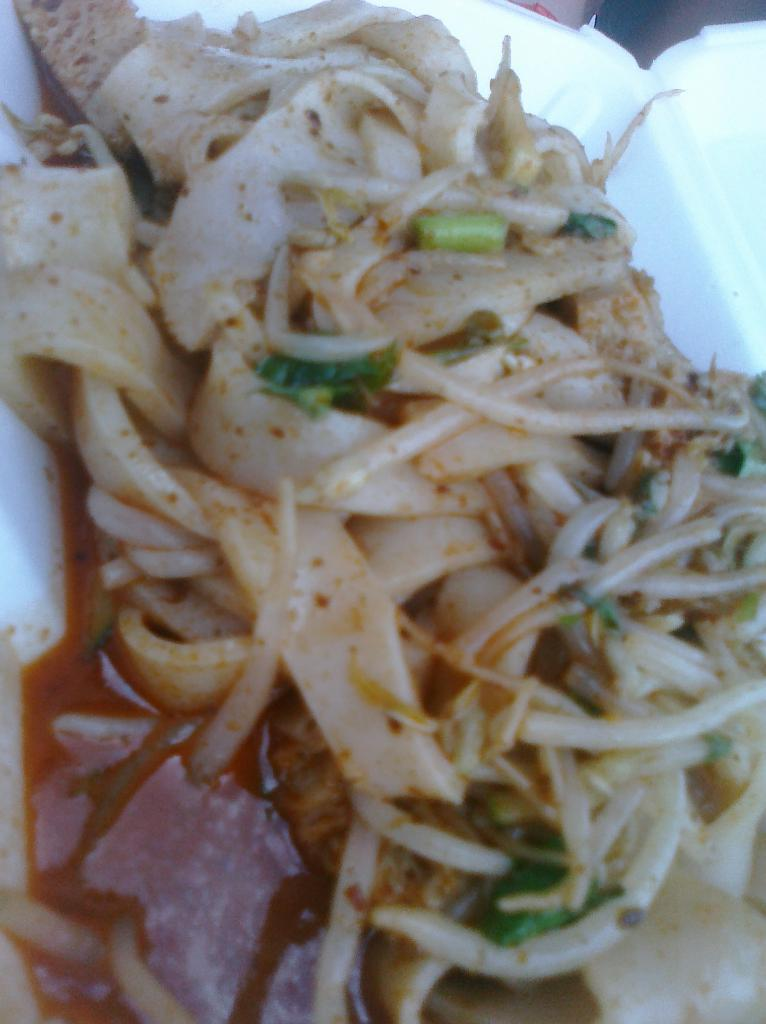What is the color of the box in the image? The box in the image is white. What is inside the box? The box contains food. What colors can be seen on the food? The food has cream, red, and green colors. What is the tax rate on the food in the image? There is no information about tax rates in the image, as it only shows a white color box containing food with cream, red, and green colors. 